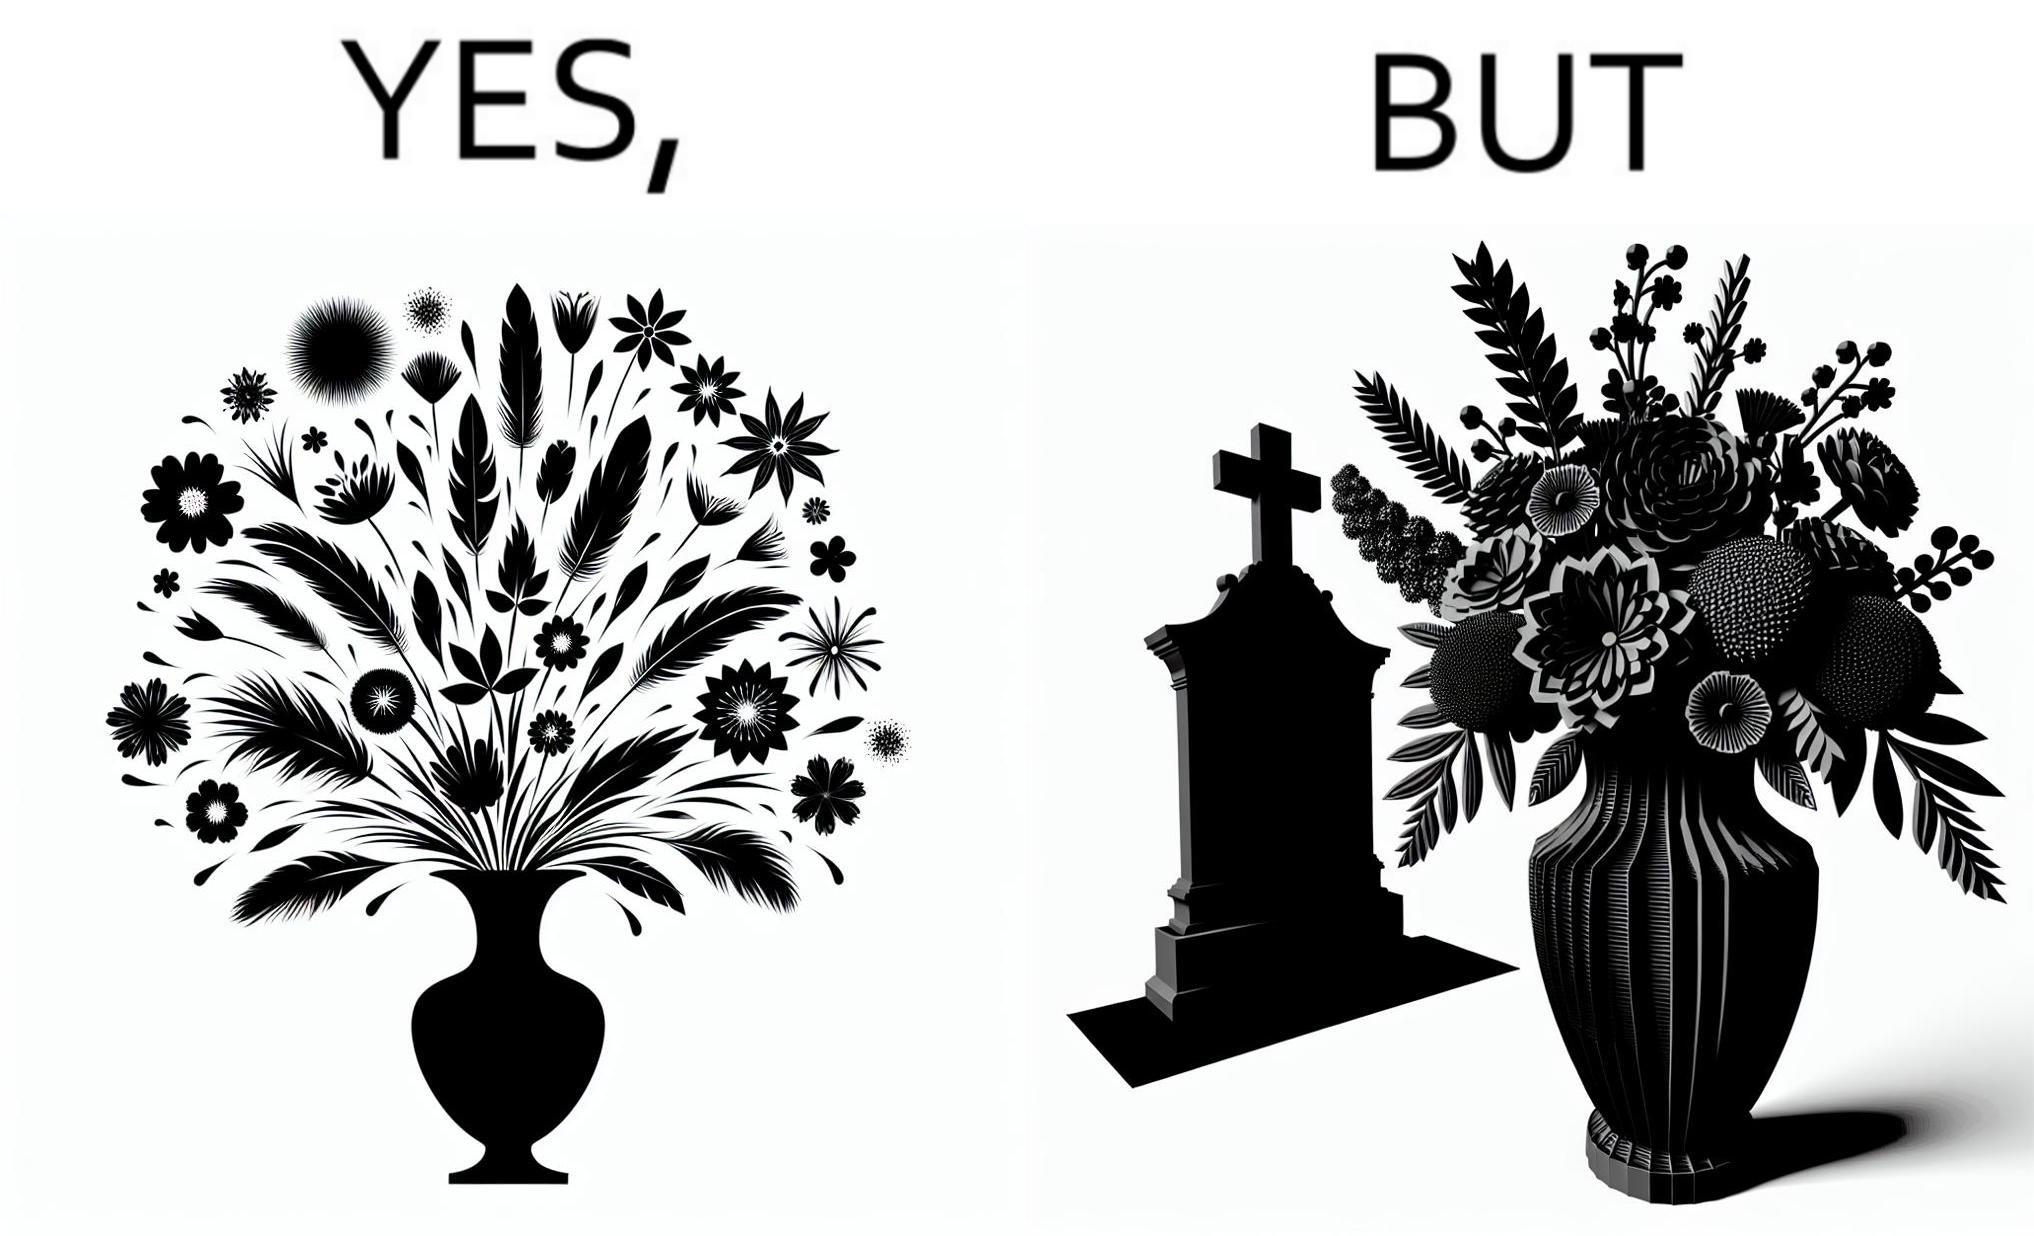Compare the left and right sides of this image. In the left part of the image: a beautiful vase of full of different beautiful flowers In the right part of the image: a beautiful vase of full of different beautiful flowers put in front of someone's grave stone 